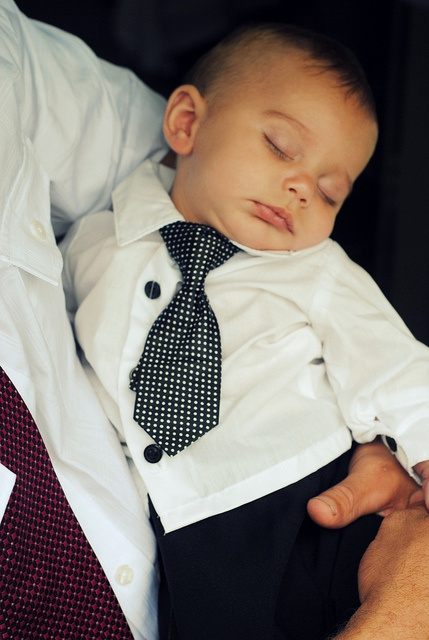Describe the objects in this image and their specific colors. I can see people in darkgray, lightgray, black, tan, and salmon tones, people in black, lightgray, and darkgray tones, tie in darkgray, black, purple, and brown tones, and tie in darkgray, black, gray, and beige tones in this image. 